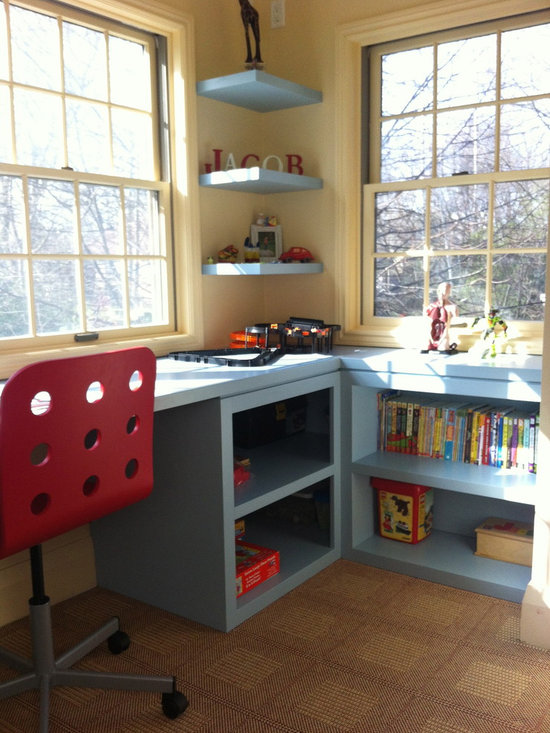Considering the items on the desk and shelves, what might be the age range of the individual who uses this space, and what are the indicators that lead to this conclusion? The workspace is likely designed for a young child, approximately between the ages of 4 to 10 years. This deduction is supported by several child-specific items observed in the space. The desk prominently features a toy train set, indicative of play-based learning tools suitable for early childhood development. Meanwhile, the shelves are populated with brightly colored children's books that cater to beginning readers, which is typical for this age range. Additionally, the playful and colorful nameplate styled in block letters is commonly appreciated by younger children. The computer monitor and its positioning also suggest its use for educational activities, reflecting a mixed use of play and learning appropriate for school-aged children. 